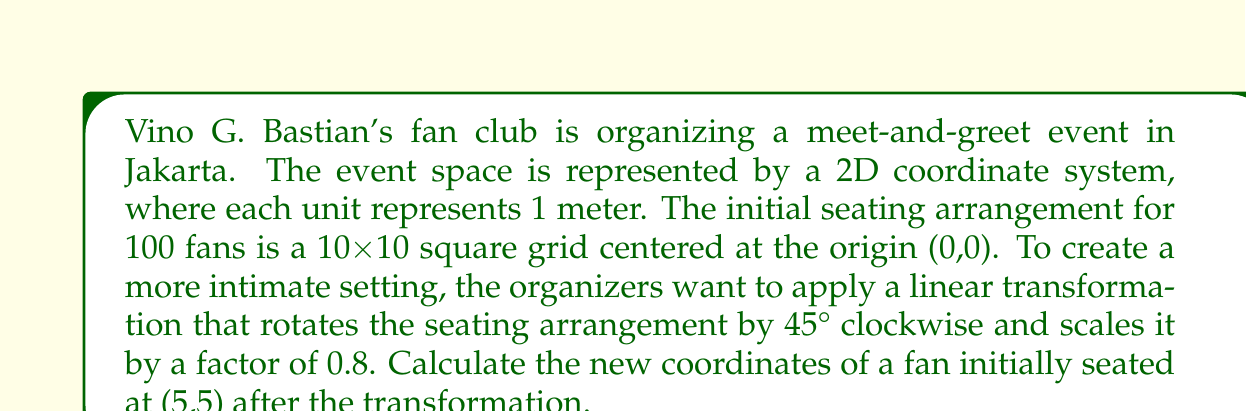Teach me how to tackle this problem. To solve this problem, we need to apply a linear transformation that combines rotation and scaling. Let's break it down step by step:

1) First, let's define the rotation matrix for a 45° clockwise rotation:
   $$R = \begin{bmatrix} \cos(-45°) & -\sin(-45°) \\ \sin(-45°) & \cos(-45°) \end{bmatrix} = \begin{bmatrix} \frac{\sqrt{2}}{2} & \frac{\sqrt{2}}{2} \\ -\frac{\sqrt{2}}{2} & \frac{\sqrt{2}}{2} \end{bmatrix}$$

2) Next, we define the scaling matrix for a scale factor of 0.8:
   $$S = \begin{bmatrix} 0.8 & 0 \\ 0 & 0.8 \end{bmatrix}$$

3) We combine these transformations by multiplying the matrices:
   $$T = SR = \begin{bmatrix} 0.8 & 0 \\ 0 & 0.8 \end{bmatrix} \begin{bmatrix} \frac{\sqrt{2}}{2} & \frac{\sqrt{2}}{2} \\ -\frac{\sqrt{2}}{2} & \frac{\sqrt{2}}{2} \end{bmatrix} = \begin{bmatrix} 0.4\sqrt{2} & 0.4\sqrt{2} \\ -0.4\sqrt{2} & 0.4\sqrt{2} \end{bmatrix}$$

4) Now, we apply this transformation to the initial coordinates (5,5):
   $$\begin{bmatrix} x' \\ y' \end{bmatrix} = T \begin{bmatrix} x \\ y \end{bmatrix} = \begin{bmatrix} 0.4\sqrt{2} & 0.4\sqrt{2} \\ -0.4\sqrt{2} & 0.4\sqrt{2} \end{bmatrix} \begin{bmatrix} 5 \\ 5 \end{bmatrix}$$

5) Calculating:
   $$\begin{bmatrix} x' \\ y' \end{bmatrix} = \begin{bmatrix} 0.4\sqrt{2}(5) + 0.4\sqrt{2}(5) \\ -0.4\sqrt{2}(5) + 0.4\sqrt{2}(5) \end{bmatrix} = \begin{bmatrix} 4\sqrt{2} \\ 0 \end{bmatrix}$$

6) Therefore, the new coordinates are $(4\sqrt{2}, 0)$, or approximately (5.66, 0) meters.
Answer: $(4\sqrt{2}, 0)$ or approximately (5.66, 0) meters 